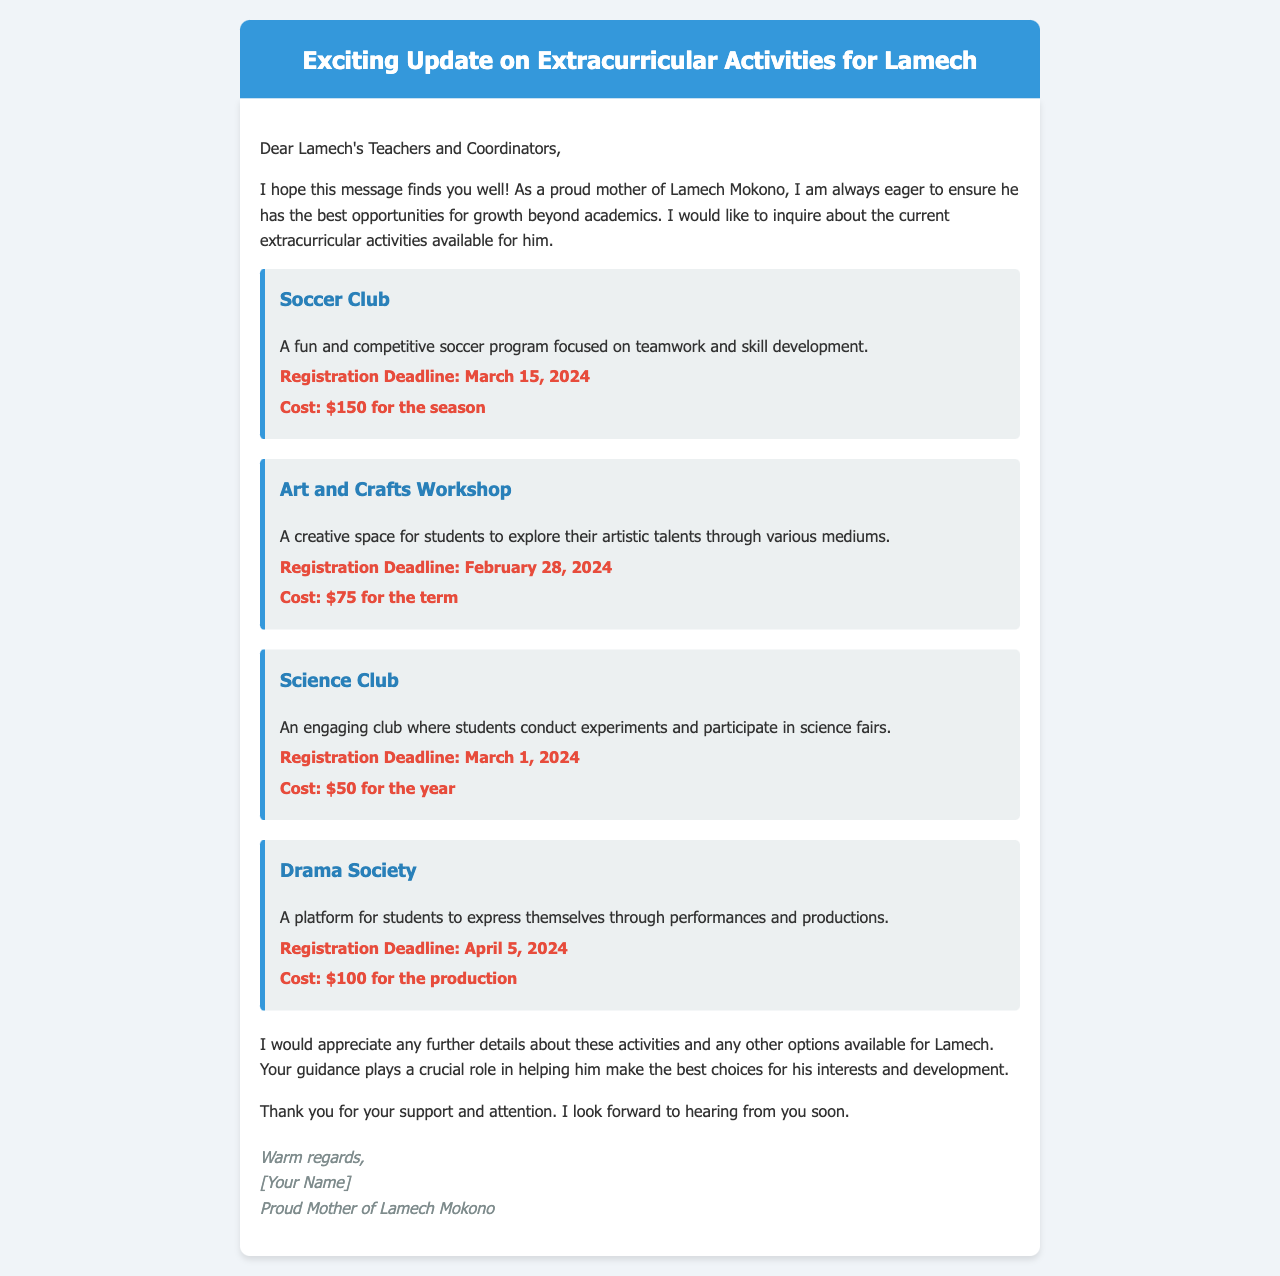What is the registration deadline for the Soccer Club? The registration deadline is specifically mentioned in the document as March 15, 2024.
Answer: March 15, 2024 What is the cost of the Art and Crafts Workshop? The document states that the cost for the Art and Crafts Workshop is $75 for the term.
Answer: $75 for the term Which activity has the earliest registration deadline? By comparing the registration deadlines listed in the document, the Art and Crafts Workshop has the earliest deadline of February 28, 2024.
Answer: February 28, 2024 What type of club is the Science Club focused on? The document describes the Science Club as engaging students to conduct experiments and participate in science fairs, indicating its focus on science.
Answer: Science What performance opportunity is offered by the Drama Society? The document specifies that the Drama Society provides a platform for students to express themselves through performances and productions.
Answer: Performances and productions How many extracurricular activities are mentioned in the document? The document lists a total of four extracurricular activities available for Lamech.
Answer: Four What is the total cost for the Soccer Club and Drama Society combined? The costs for the Soccer Club and Drama Society combined amount to $150 for the season and $100 for the production, totaling $250.
Answer: $250 What is the primary audience of the email? The document is addressed to Lamech's teachers and coordinators, indicating the intended audience for the message.
Answer: Lamech's teachers and coordinators 